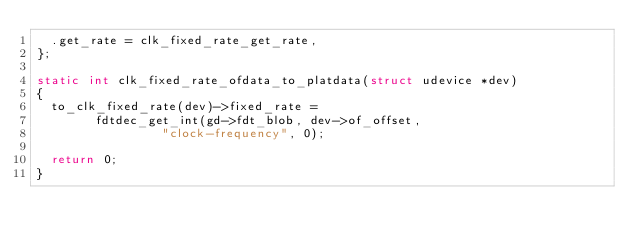<code> <loc_0><loc_0><loc_500><loc_500><_C_>	.get_rate = clk_fixed_rate_get_rate,
};

static int clk_fixed_rate_ofdata_to_platdata(struct udevice *dev)
{
	to_clk_fixed_rate(dev)->fixed_rate =
				fdtdec_get_int(gd->fdt_blob, dev->of_offset,
					       "clock-frequency", 0);

	return 0;
}
</code> 